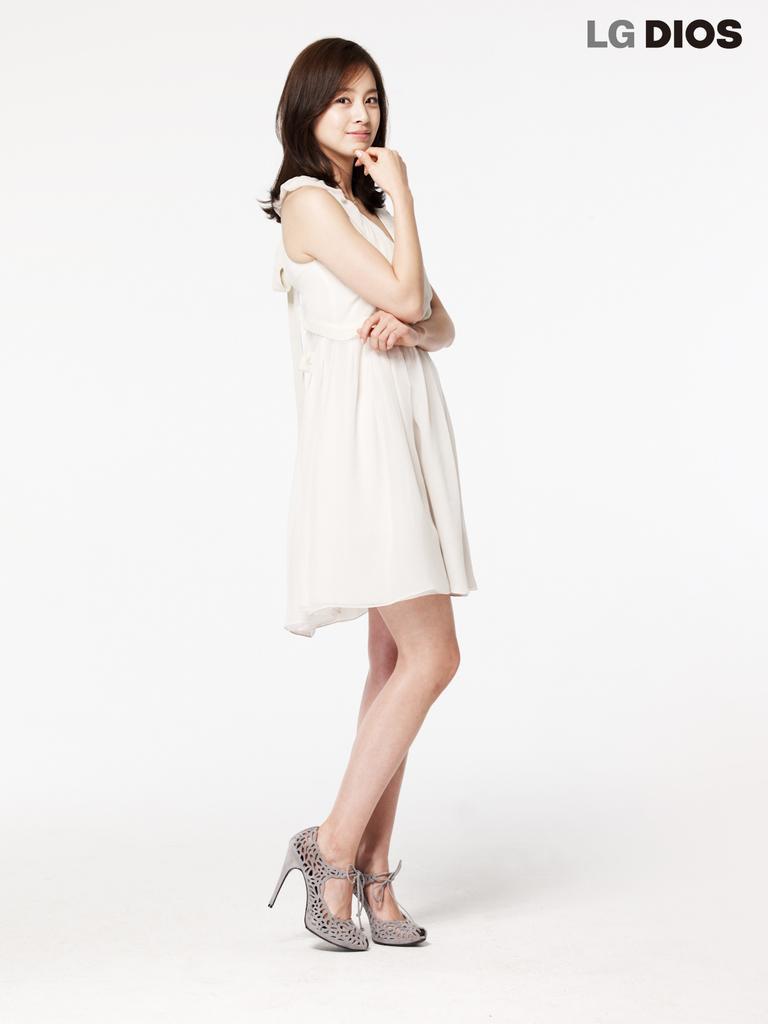In one or two sentences, can you explain what this image depicts? In this image we can see a person and some text at the top. 